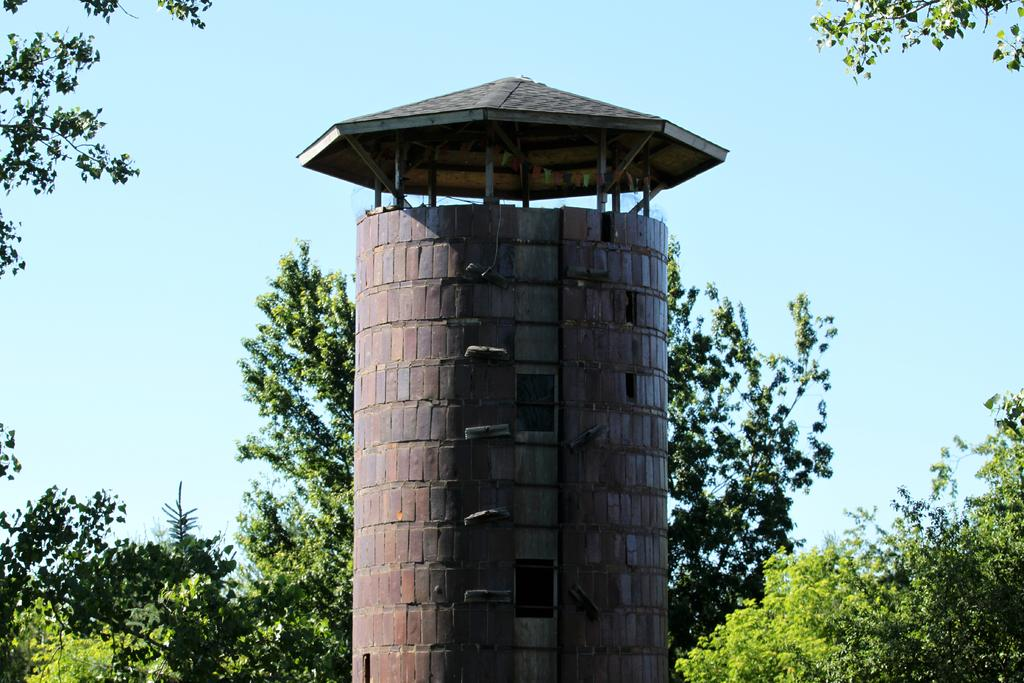What is the main object in the foreground of the image? There is an object in the foreground that resembles a minaret. What is on top of the minaret-like object? There is a tent on the minaret-like object. What type of natural environment can be seen in the image? Trees are visible in the image. What is visible in the background of the image? The sky is visible in the image. What is the tax rate for the trail in the image? There is no trail or tax rate mentioned in the image; it features a minaret-like object with a tent and trees in the background. How many lines can be seen in the image? There is no mention of lines in the image; it primarily consists of a minaret-like object, a tent, trees, and the sky. 